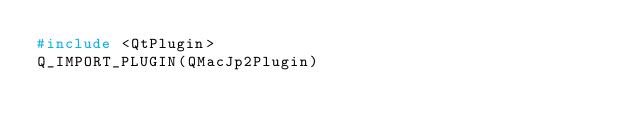<code> <loc_0><loc_0><loc_500><loc_500><_C++_>#include <QtPlugin>
Q_IMPORT_PLUGIN(QMacJp2Plugin)
</code> 